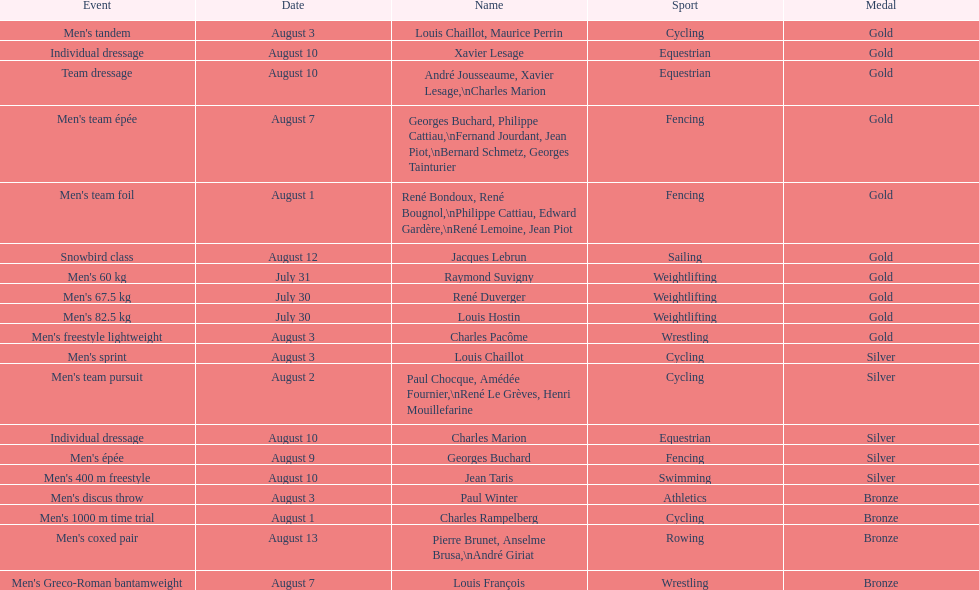What sport did louis challiot win the same medal as paul chocque in? Cycling. 